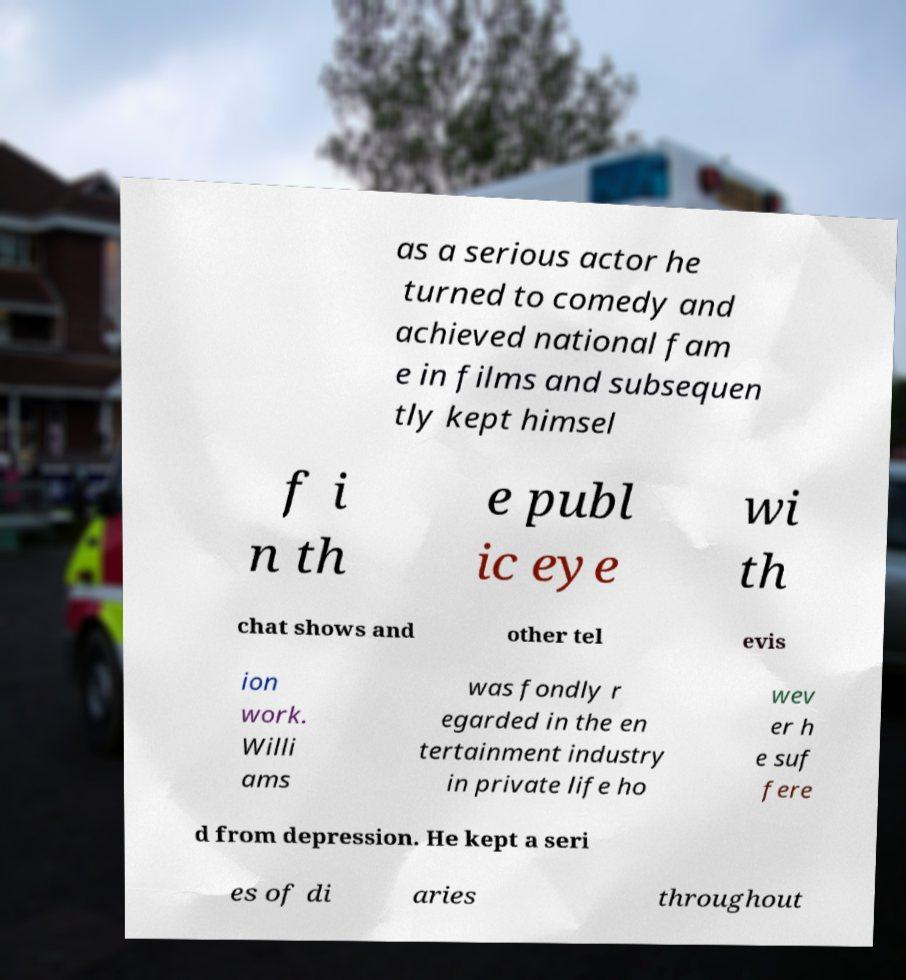Can you read and provide the text displayed in the image?This photo seems to have some interesting text. Can you extract and type it out for me? as a serious actor he turned to comedy and achieved national fam e in films and subsequen tly kept himsel f i n th e publ ic eye wi th chat shows and other tel evis ion work. Willi ams was fondly r egarded in the en tertainment industry in private life ho wev er h e suf fere d from depression. He kept a seri es of di aries throughout 